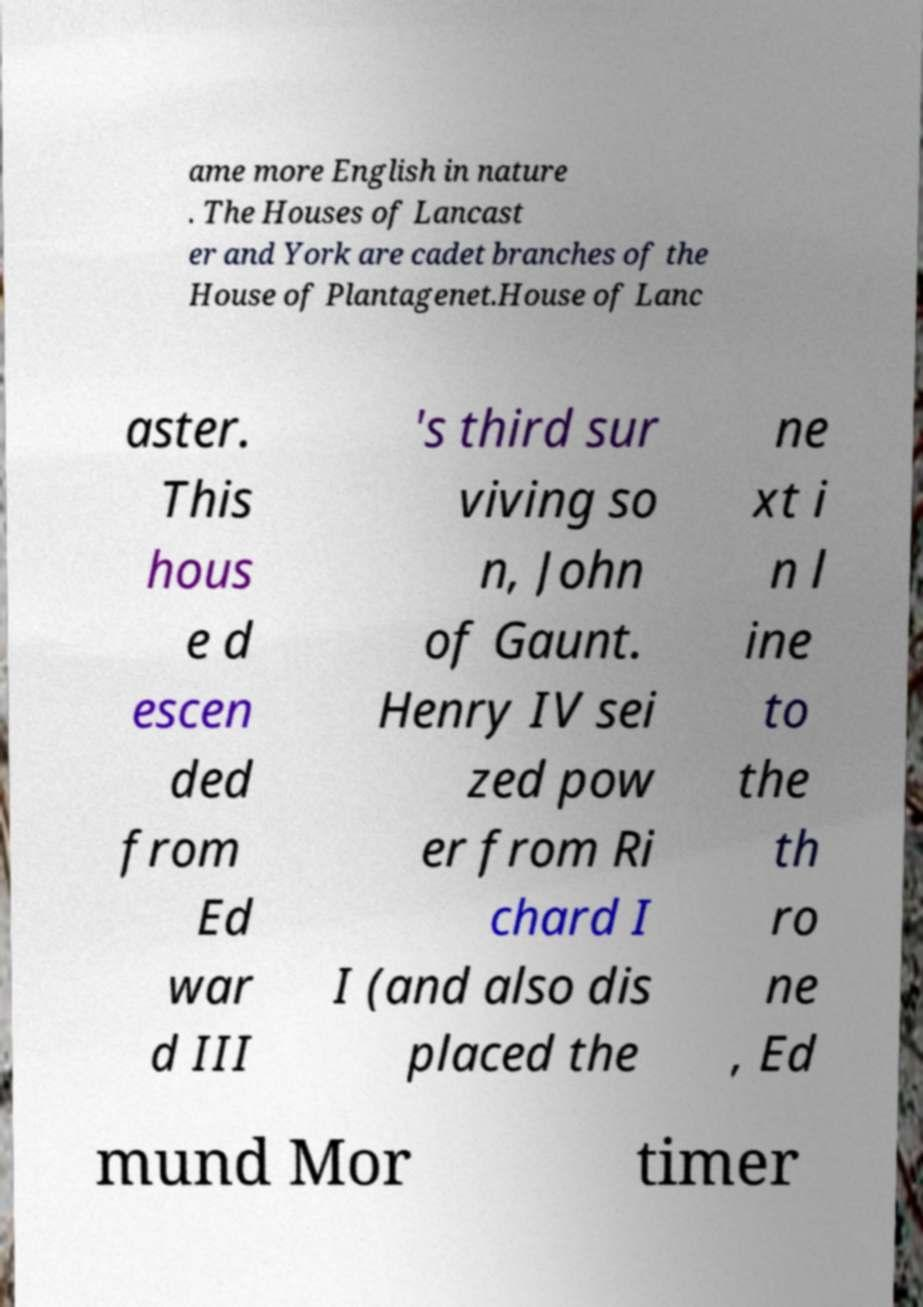There's text embedded in this image that I need extracted. Can you transcribe it verbatim? ame more English in nature . The Houses of Lancast er and York are cadet branches of the House of Plantagenet.House of Lanc aster. This hous e d escen ded from Ed war d III 's third sur viving so n, John of Gaunt. Henry IV sei zed pow er from Ri chard I I (and also dis placed the ne xt i n l ine to the th ro ne , Ed mund Mor timer 